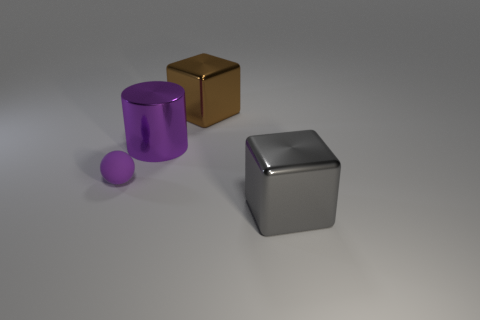How many objects are things on the left side of the gray metallic block or tiny yellow rubber cylinders?
Provide a short and direct response. 3. Is the size of the shiny block behind the tiny purple ball the same as the purple thing that is in front of the purple cylinder?
Give a very brief answer. No. Is there any other thing that is the same material as the large brown cube?
Keep it short and to the point. Yes. What number of objects are large objects right of the large purple cylinder or things on the left side of the purple shiny thing?
Your answer should be compact. 3. Does the sphere have the same material as the big cube behind the purple cylinder?
Your answer should be compact. No. What is the shape of the object that is both in front of the metallic cylinder and to the left of the gray thing?
Offer a terse response. Sphere. What number of other things are there of the same color as the ball?
Provide a short and direct response. 1. What is the shape of the small purple object?
Your answer should be very brief. Sphere. There is a large metallic cube that is in front of the shiny cube behind the large gray object; what is its color?
Keep it short and to the point. Gray. Do the rubber object and the metallic cube that is behind the purple matte object have the same color?
Give a very brief answer. No. 